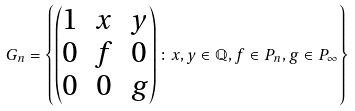Convert formula to latex. <formula><loc_0><loc_0><loc_500><loc_500>G _ { n } = \left \{ \left ( \begin{matrix} 1 & x & y \\ 0 & f & 0 \\ 0 & 0 & g \end{matrix} \right ) \colon x , y \in \mathbb { Q } , f \in P _ { n } , g \in P _ { \infty } \right \}</formula> 